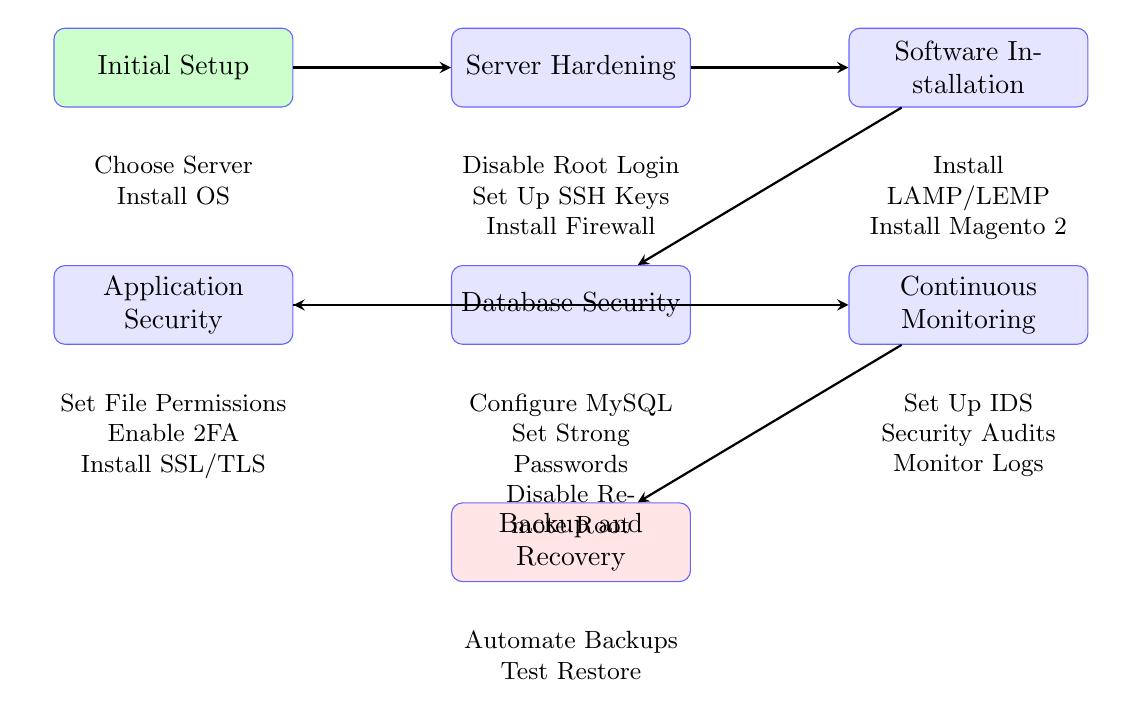What is the first step in the flow chart? The first step listed in the flow chart is "Initial Setup," which includes choosing a dedicated server and installing the operating system. This is shown as the top node in the diagram.
Answer: Initial Setup How many nodes are present in the diagram? Count the distinct blocks in the flow chart, each representing a stage of the setup process. There are a total of seven blocks or nodes, including "Initial Setup," "Server Hardening," "Software Installation," "Database Security," "Application Security," "Continuous Monitoring," and "Backup and Recovery."
Answer: Seven What actions are included in the "Server Hardening" step? The "Server Hardening" step has three actions: "Disable Root Login," "Set Up SSH Keys," and "Install Firewall." These actions are listed below the corresponding node in the diagram.
Answer: Disable Root Login, Set Up SSH Keys, Install Firewall Which node comes before "Continuous Monitoring"? To determine which node precedes "Continuous Monitoring," follow the arrows from "Continuous Monitoring" backward. The node that leads directly into "Continuous Monitoring" is "Application Security."
Answer: Application Security What is the final step in the flow chart? The last node at the bottom of the flow chart indicates the last step in the process, which is "Backup and Recovery." It is positioned below the "Continuous Monitoring" node, making it clear that it is the final stage.
Answer: Backup and Recovery How many actions are listed under "Database Security"? Check the number of actions listed under the "Database Security" node. There are three actions detailed in this step: "Install and Configure MySQL/MariaDB," "Set Strong Database Passwords," and "Disable Remote Root Access." Counting these gives a total of three.
Answer: Three Which step involves the installation of an SSL/TLS certificate? The step that incorporates the installation of an SSL/TLS certificate is "Application Security." This can be confirmed by looking at the actions listed in that specific node.
Answer: Application Security What must be automated according to the "Backup and Recovery" step? The "Backup and Recovery" step emphasizes the need for "Automate Regular Backups." This is clearly stated as one of the actions required in that final node.
Answer: Automate Regular Backups 